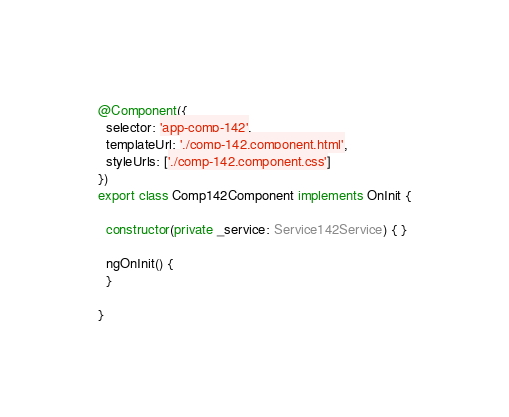<code> <loc_0><loc_0><loc_500><loc_500><_TypeScript_>@Component({
  selector: 'app-comp-142',
  templateUrl: './comp-142.component.html',
  styleUrls: ['./comp-142.component.css']
})
export class Comp142Component implements OnInit {

  constructor(private _service: Service142Service) { }

  ngOnInit() {
  }

}
</code> 